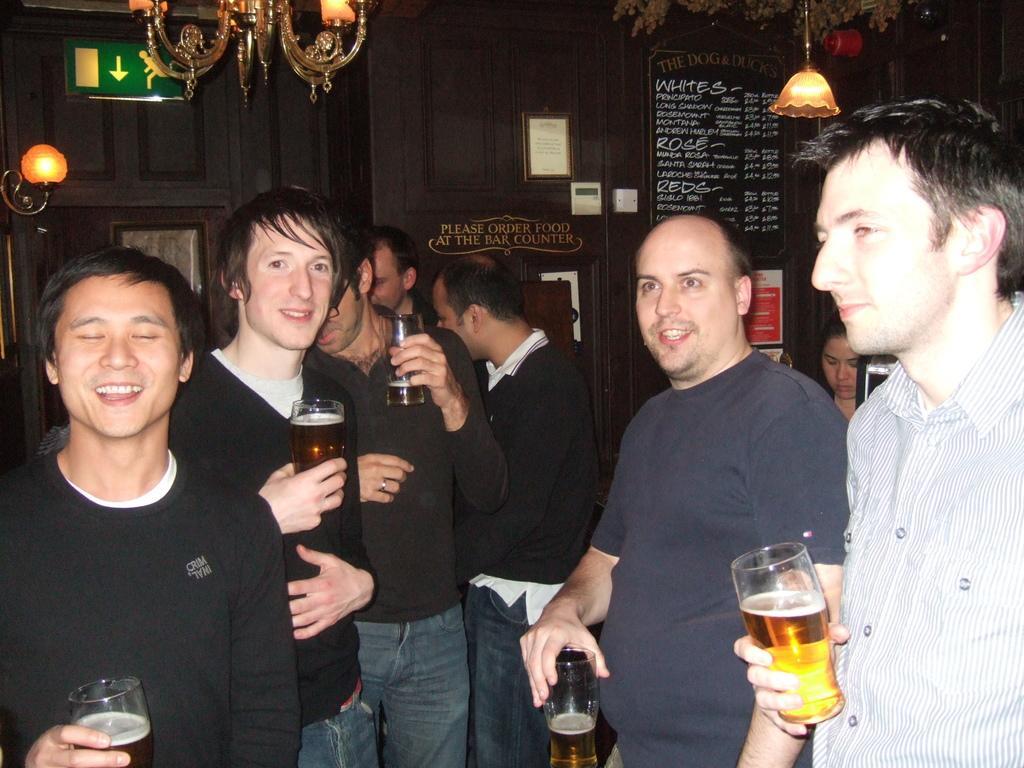In one or two sentences, can you explain what this image depicts? Here we can see a five person. They are having a drink and the person on the left side is having a smile on his face. 